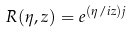<formula> <loc_0><loc_0><loc_500><loc_500>R ( \eta , z ) = e ^ { ( \eta / i z ) j }</formula> 